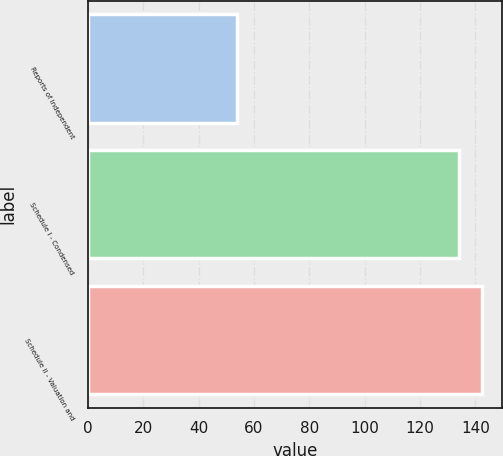Convert chart. <chart><loc_0><loc_0><loc_500><loc_500><bar_chart><fcel>Reports of Independent<fcel>Schedule I - Condensed<fcel>Schedule II - Valuation and<nl><fcel>54<fcel>134<fcel>142.4<nl></chart> 